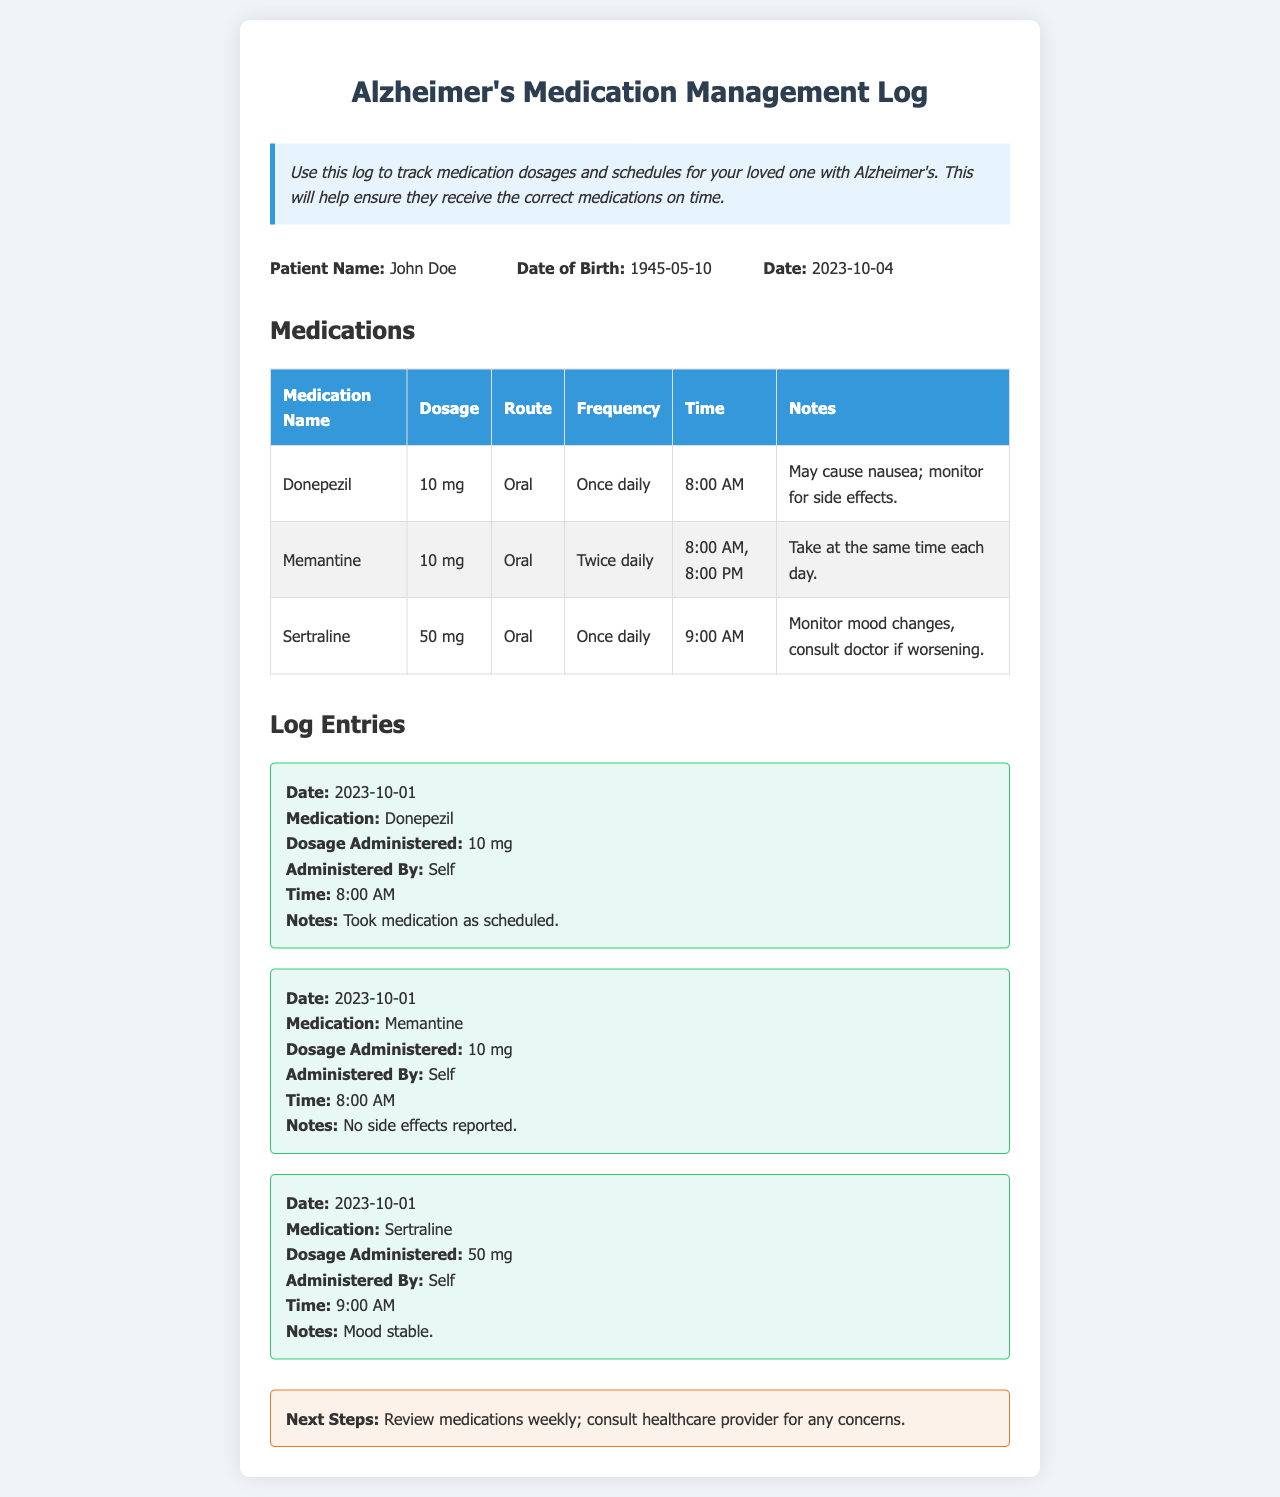what is the patient's name? The patient’s name is listed in the patient info section of the document.
Answer: John Doe what is the dosage of Donepezil? The dosage is specified in the medications table.
Answer: 10 mg how many times a day is Memantine taken? The frequency for Memantine is indicated in the medications table.
Answer: Twice daily what time is Sertraline administered? The specific time for Sertraline is found in the medications table.
Answer: 9:00 AM what is a noted side effect of Donepezil? The notes section of the medication entry provides this information.
Answer: Nausea when was the last log entry recorded? This information is found in the log entries section.
Answer: 2023-10-01 who administered the medication for Memantine? The entry for Memantine in the log specifies who administered it.
Answer: Self what should be done weekly according to the next steps? The next steps section gives guidance on what needs to be done.
Answer: Review medications how many medications are listed in the table? The medications table contains the list of medications for tracking.
Answer: Three 